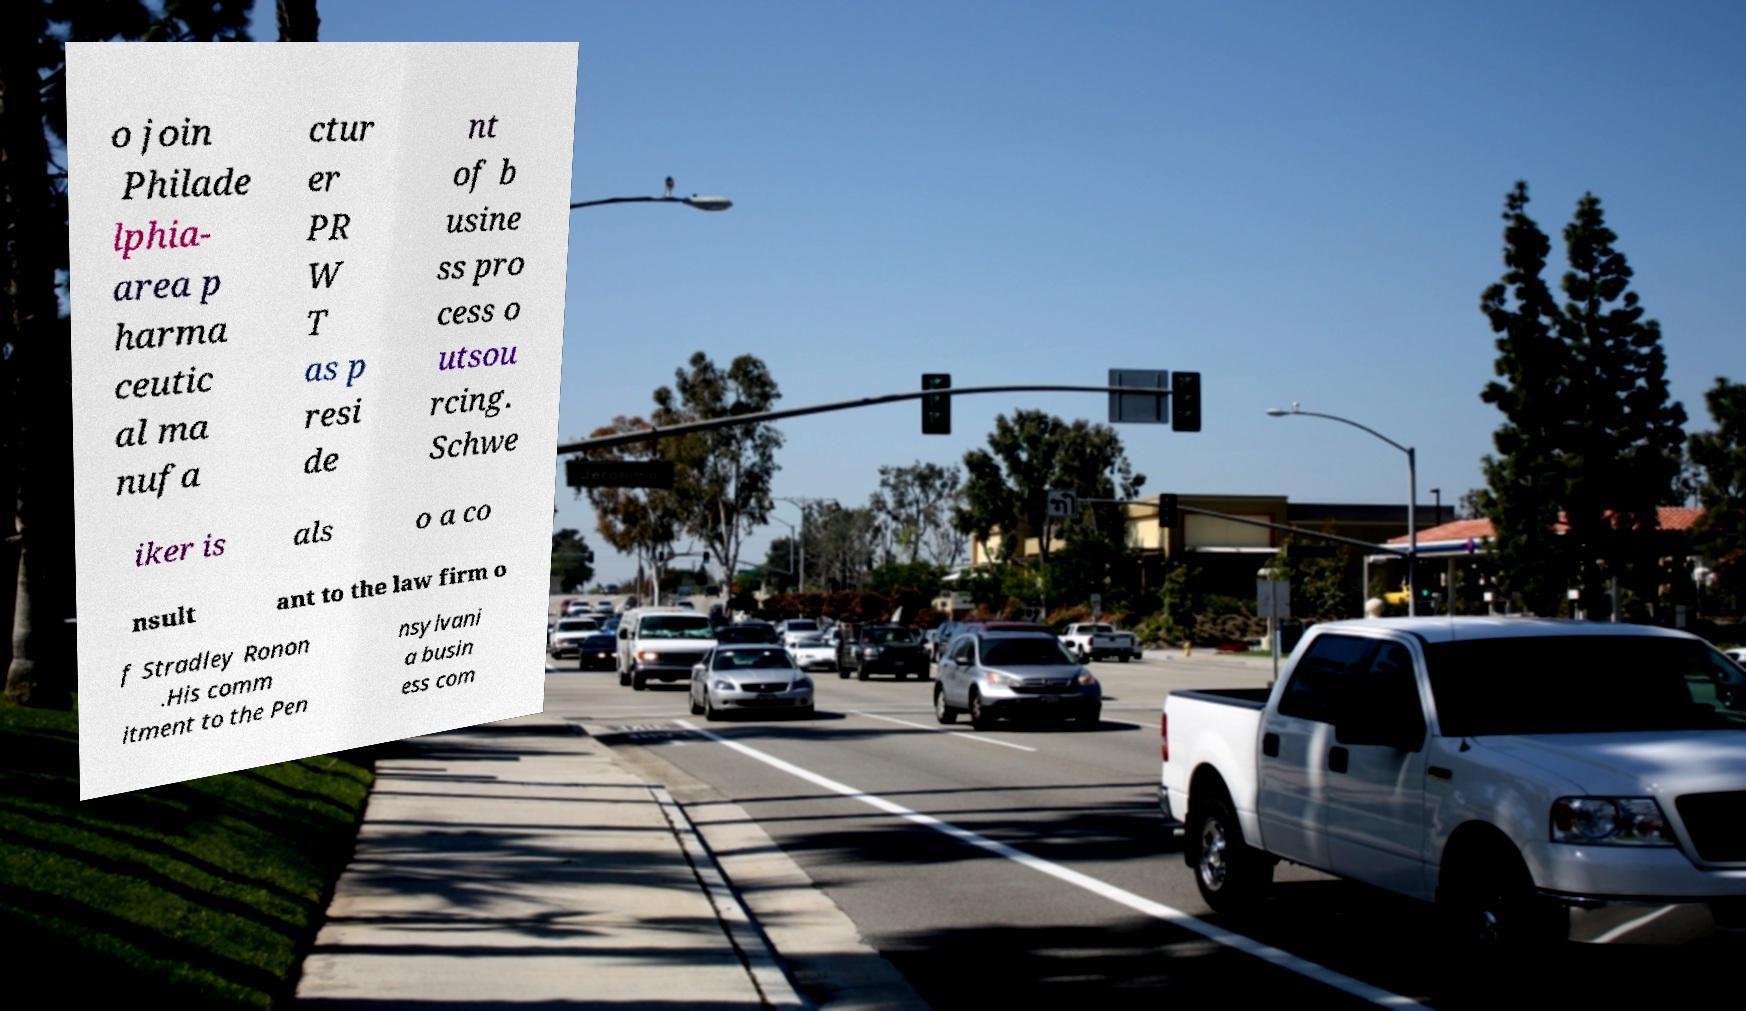Could you assist in decoding the text presented in this image and type it out clearly? o join Philade lphia- area p harma ceutic al ma nufa ctur er PR W T as p resi de nt of b usine ss pro cess o utsou rcing. Schwe iker is als o a co nsult ant to the law firm o f Stradley Ronon .His comm itment to the Pen nsylvani a busin ess com 